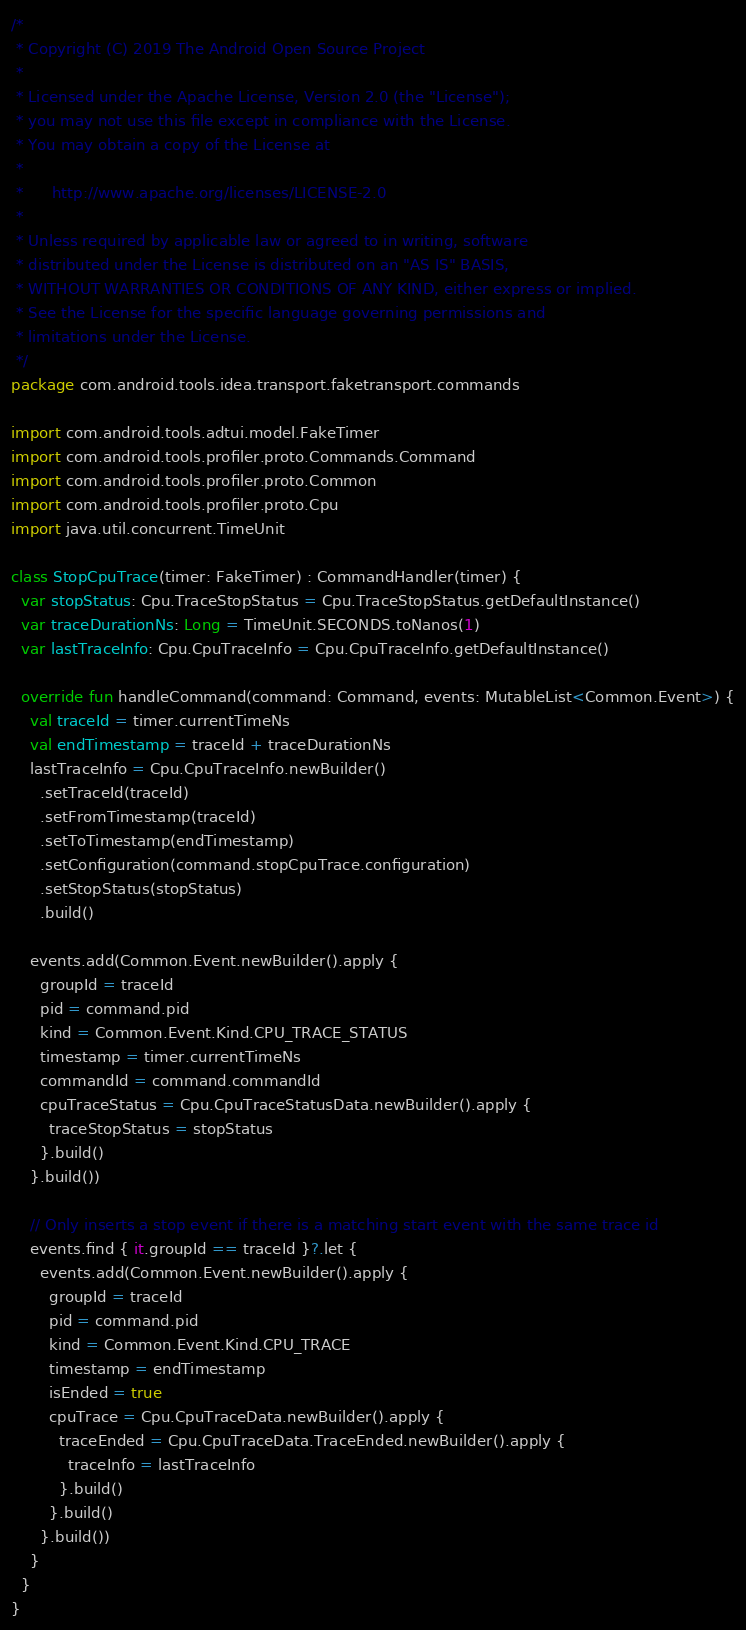Convert code to text. <code><loc_0><loc_0><loc_500><loc_500><_Kotlin_>/*
 * Copyright (C) 2019 The Android Open Source Project
 *
 * Licensed under the Apache License, Version 2.0 (the "License");
 * you may not use this file except in compliance with the License.
 * You may obtain a copy of the License at
 *
 *      http://www.apache.org/licenses/LICENSE-2.0
 *
 * Unless required by applicable law or agreed to in writing, software
 * distributed under the License is distributed on an "AS IS" BASIS,
 * WITHOUT WARRANTIES OR CONDITIONS OF ANY KIND, either express or implied.
 * See the License for the specific language governing permissions and
 * limitations under the License.
 */
package com.android.tools.idea.transport.faketransport.commands

import com.android.tools.adtui.model.FakeTimer
import com.android.tools.profiler.proto.Commands.Command
import com.android.tools.profiler.proto.Common
import com.android.tools.profiler.proto.Cpu
import java.util.concurrent.TimeUnit

class StopCpuTrace(timer: FakeTimer) : CommandHandler(timer) {
  var stopStatus: Cpu.TraceStopStatus = Cpu.TraceStopStatus.getDefaultInstance()
  var traceDurationNs: Long = TimeUnit.SECONDS.toNanos(1)
  var lastTraceInfo: Cpu.CpuTraceInfo = Cpu.CpuTraceInfo.getDefaultInstance()

  override fun handleCommand(command: Command, events: MutableList<Common.Event>) {
    val traceId = timer.currentTimeNs
    val endTimestamp = traceId + traceDurationNs
    lastTraceInfo = Cpu.CpuTraceInfo.newBuilder()
      .setTraceId(traceId)
      .setFromTimestamp(traceId)
      .setToTimestamp(endTimestamp)
      .setConfiguration(command.stopCpuTrace.configuration)
      .setStopStatus(stopStatus)
      .build()

    events.add(Common.Event.newBuilder().apply {
      groupId = traceId
      pid = command.pid
      kind = Common.Event.Kind.CPU_TRACE_STATUS
      timestamp = timer.currentTimeNs
      commandId = command.commandId
      cpuTraceStatus = Cpu.CpuTraceStatusData.newBuilder().apply {
        traceStopStatus = stopStatus
      }.build()
    }.build())

    // Only inserts a stop event if there is a matching start event with the same trace id
    events.find { it.groupId == traceId }?.let {
      events.add(Common.Event.newBuilder().apply {
        groupId = traceId
        pid = command.pid
        kind = Common.Event.Kind.CPU_TRACE
        timestamp = endTimestamp
        isEnded = true
        cpuTrace = Cpu.CpuTraceData.newBuilder().apply {
          traceEnded = Cpu.CpuTraceData.TraceEnded.newBuilder().apply {
            traceInfo = lastTraceInfo
          }.build()
        }.build()
      }.build())
    }
  }
}
</code> 